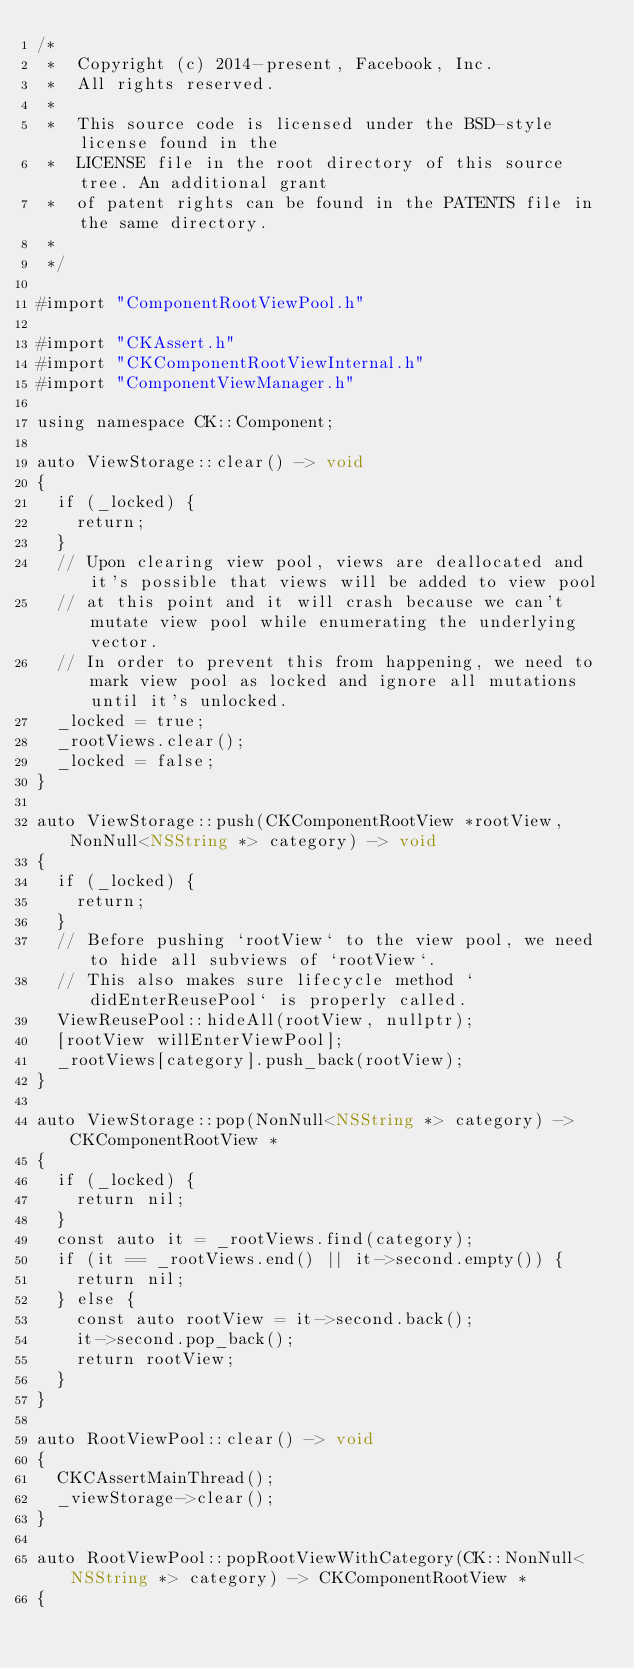<code> <loc_0><loc_0><loc_500><loc_500><_ObjectiveC_>/*
 *  Copyright (c) 2014-present, Facebook, Inc.
 *  All rights reserved.
 *
 *  This source code is licensed under the BSD-style license found in the
 *  LICENSE file in the root directory of this source tree. An additional grant
 *  of patent rights can be found in the PATENTS file in the same directory.
 *
 */

#import "ComponentRootViewPool.h"

#import "CKAssert.h"
#import "CKComponentRootViewInternal.h"
#import "ComponentViewManager.h"

using namespace CK::Component;

auto ViewStorage::clear() -> void
{
  if (_locked) {
    return;
  }
  // Upon clearing view pool, views are deallocated and it's possible that views will be added to view pool
  // at this point and it will crash because we can't mutate view pool while enumerating the underlying vector.
  // In order to prevent this from happening, we need to mark view pool as locked and ignore all mutations until it's unlocked.
  _locked = true;
  _rootViews.clear();
  _locked = false;
}

auto ViewStorage::push(CKComponentRootView *rootView, NonNull<NSString *> category) -> void
{
  if (_locked) {
    return;
  }
  // Before pushing `rootView` to the view pool, we need to hide all subviews of `rootView`.
  // This also makes sure lifecycle method `didEnterReusePool` is properly called.
  ViewReusePool::hideAll(rootView, nullptr);
  [rootView willEnterViewPool];
  _rootViews[category].push_back(rootView);
}

auto ViewStorage::pop(NonNull<NSString *> category) -> CKComponentRootView *
{
  if (_locked) {
    return nil;
  }
  const auto it = _rootViews.find(category);
  if (it == _rootViews.end() || it->second.empty()) {
    return nil;
  } else {
    const auto rootView = it->second.back();
    it->second.pop_back();
    return rootView;
  }
}

auto RootViewPool::clear() -> void
{
  CKCAssertMainThread();
  _viewStorage->clear();
}

auto RootViewPool::popRootViewWithCategory(CK::NonNull<NSString *> category) -> CKComponentRootView *
{</code> 